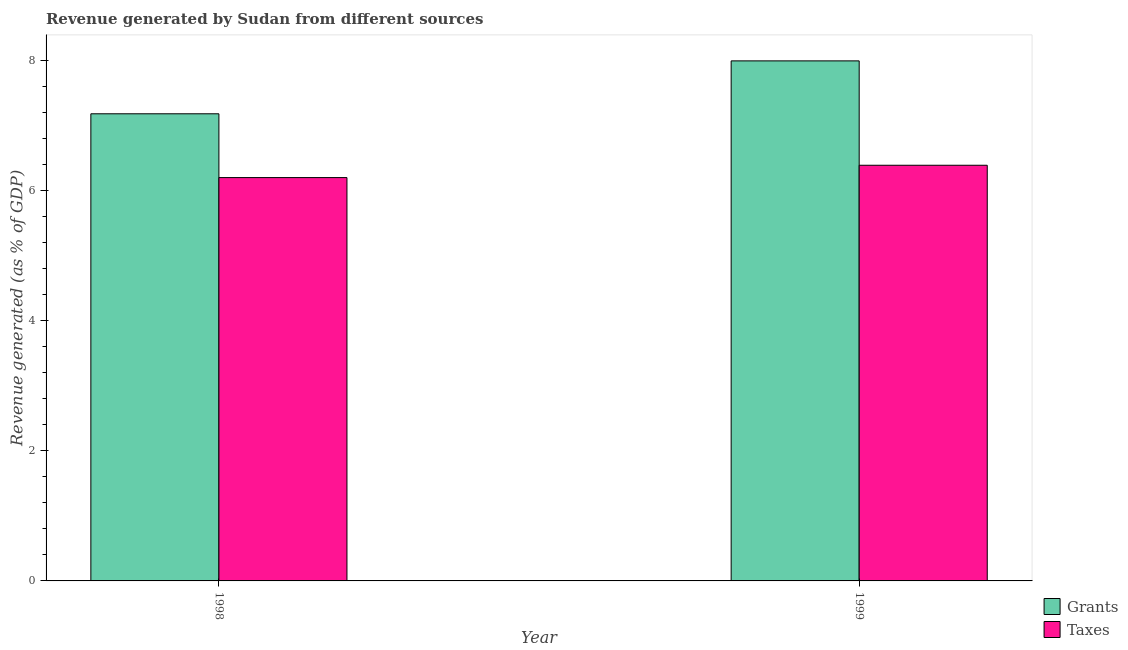Are the number of bars on each tick of the X-axis equal?
Make the answer very short. Yes. How many bars are there on the 1st tick from the right?
Provide a succinct answer. 2. What is the label of the 2nd group of bars from the left?
Provide a short and direct response. 1999. What is the revenue generated by grants in 1998?
Make the answer very short. 7.18. Across all years, what is the maximum revenue generated by grants?
Your answer should be compact. 7.99. Across all years, what is the minimum revenue generated by grants?
Give a very brief answer. 7.18. What is the total revenue generated by taxes in the graph?
Your answer should be compact. 12.58. What is the difference between the revenue generated by grants in 1998 and that in 1999?
Your response must be concise. -0.81. What is the difference between the revenue generated by taxes in 1999 and the revenue generated by grants in 1998?
Make the answer very short. 0.19. What is the average revenue generated by taxes per year?
Provide a succinct answer. 6.29. In how many years, is the revenue generated by grants greater than 2.4 %?
Provide a succinct answer. 2. What is the ratio of the revenue generated by grants in 1998 to that in 1999?
Keep it short and to the point. 0.9. In how many years, is the revenue generated by taxes greater than the average revenue generated by taxes taken over all years?
Make the answer very short. 1. What does the 2nd bar from the left in 1998 represents?
Offer a very short reply. Taxes. What does the 1st bar from the right in 1998 represents?
Keep it short and to the point. Taxes. How many bars are there?
Your answer should be compact. 4. How many years are there in the graph?
Your response must be concise. 2. What is the difference between two consecutive major ticks on the Y-axis?
Your answer should be very brief. 2. Are the values on the major ticks of Y-axis written in scientific E-notation?
Give a very brief answer. No. Does the graph contain any zero values?
Provide a succinct answer. No. How are the legend labels stacked?
Your answer should be compact. Vertical. What is the title of the graph?
Keep it short and to the point. Revenue generated by Sudan from different sources. What is the label or title of the Y-axis?
Give a very brief answer. Revenue generated (as % of GDP). What is the Revenue generated (as % of GDP) in Grants in 1998?
Provide a short and direct response. 7.18. What is the Revenue generated (as % of GDP) of Taxes in 1998?
Your response must be concise. 6.2. What is the Revenue generated (as % of GDP) in Grants in 1999?
Make the answer very short. 7.99. What is the Revenue generated (as % of GDP) in Taxes in 1999?
Make the answer very short. 6.39. Across all years, what is the maximum Revenue generated (as % of GDP) in Grants?
Make the answer very short. 7.99. Across all years, what is the maximum Revenue generated (as % of GDP) in Taxes?
Offer a terse response. 6.39. Across all years, what is the minimum Revenue generated (as % of GDP) in Grants?
Offer a terse response. 7.18. Across all years, what is the minimum Revenue generated (as % of GDP) of Taxes?
Provide a short and direct response. 6.2. What is the total Revenue generated (as % of GDP) in Grants in the graph?
Make the answer very short. 15.17. What is the total Revenue generated (as % of GDP) of Taxes in the graph?
Your response must be concise. 12.58. What is the difference between the Revenue generated (as % of GDP) in Grants in 1998 and that in 1999?
Provide a short and direct response. -0.81. What is the difference between the Revenue generated (as % of GDP) in Taxes in 1998 and that in 1999?
Your answer should be compact. -0.19. What is the difference between the Revenue generated (as % of GDP) in Grants in 1998 and the Revenue generated (as % of GDP) in Taxes in 1999?
Provide a succinct answer. 0.79. What is the average Revenue generated (as % of GDP) in Grants per year?
Offer a very short reply. 7.58. What is the average Revenue generated (as % of GDP) of Taxes per year?
Offer a very short reply. 6.29. In the year 1998, what is the difference between the Revenue generated (as % of GDP) in Grants and Revenue generated (as % of GDP) in Taxes?
Ensure brevity in your answer.  0.98. In the year 1999, what is the difference between the Revenue generated (as % of GDP) of Grants and Revenue generated (as % of GDP) of Taxes?
Your answer should be compact. 1.6. What is the ratio of the Revenue generated (as % of GDP) in Grants in 1998 to that in 1999?
Your answer should be very brief. 0.9. What is the ratio of the Revenue generated (as % of GDP) of Taxes in 1998 to that in 1999?
Offer a very short reply. 0.97. What is the difference between the highest and the second highest Revenue generated (as % of GDP) of Grants?
Keep it short and to the point. 0.81. What is the difference between the highest and the second highest Revenue generated (as % of GDP) of Taxes?
Make the answer very short. 0.19. What is the difference between the highest and the lowest Revenue generated (as % of GDP) in Grants?
Offer a very short reply. 0.81. What is the difference between the highest and the lowest Revenue generated (as % of GDP) in Taxes?
Give a very brief answer. 0.19. 